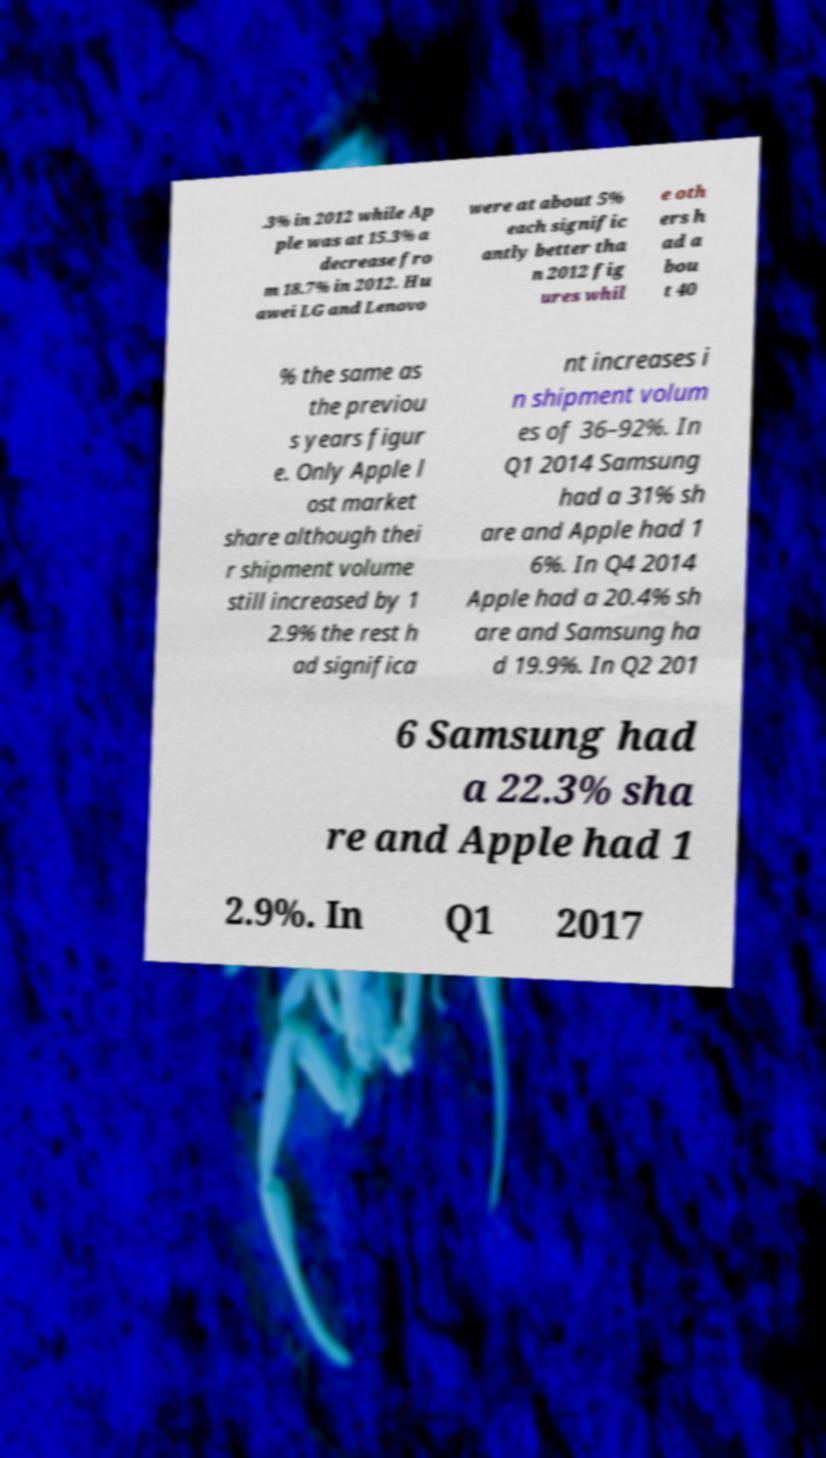Please identify and transcribe the text found in this image. .3% in 2012 while Ap ple was at 15.3% a decrease fro m 18.7% in 2012. Hu awei LG and Lenovo were at about 5% each signific antly better tha n 2012 fig ures whil e oth ers h ad a bou t 40 % the same as the previou s years figur e. Only Apple l ost market share although thei r shipment volume still increased by 1 2.9% the rest h ad significa nt increases i n shipment volum es of 36–92%. In Q1 2014 Samsung had a 31% sh are and Apple had 1 6%. In Q4 2014 Apple had a 20.4% sh are and Samsung ha d 19.9%. In Q2 201 6 Samsung had a 22.3% sha re and Apple had 1 2.9%. In Q1 2017 